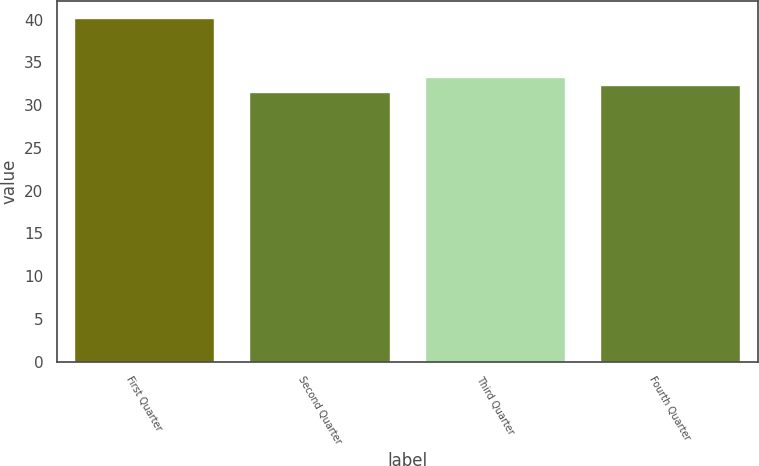<chart> <loc_0><loc_0><loc_500><loc_500><bar_chart><fcel>First Quarter<fcel>Second Quarter<fcel>Third Quarter<fcel>Fourth Quarter<nl><fcel>40.22<fcel>31.53<fcel>33.27<fcel>32.4<nl></chart> 